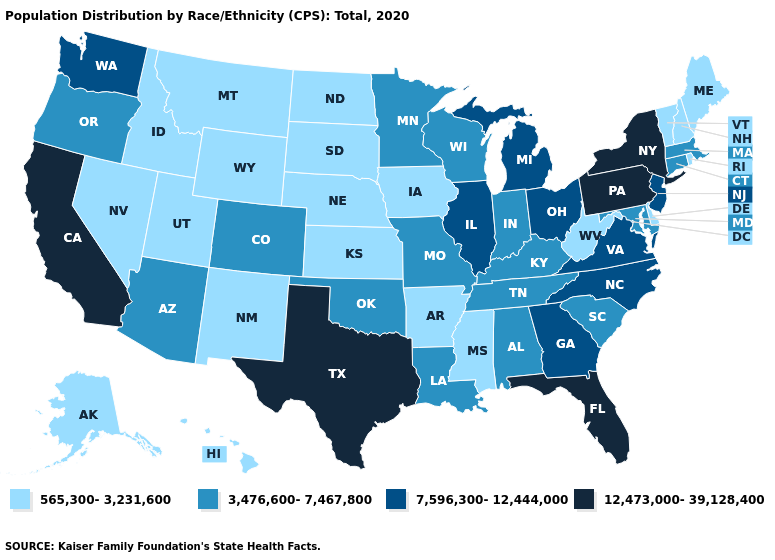What is the value of Kansas?
Answer briefly. 565,300-3,231,600. Name the states that have a value in the range 565,300-3,231,600?
Short answer required. Alaska, Arkansas, Delaware, Hawaii, Idaho, Iowa, Kansas, Maine, Mississippi, Montana, Nebraska, Nevada, New Hampshire, New Mexico, North Dakota, Rhode Island, South Dakota, Utah, Vermont, West Virginia, Wyoming. What is the value of Florida?
Concise answer only. 12,473,000-39,128,400. Which states have the lowest value in the South?
Give a very brief answer. Arkansas, Delaware, Mississippi, West Virginia. Name the states that have a value in the range 12,473,000-39,128,400?
Short answer required. California, Florida, New York, Pennsylvania, Texas. Among the states that border Oregon , which have the highest value?
Write a very short answer. California. Name the states that have a value in the range 7,596,300-12,444,000?
Keep it brief. Georgia, Illinois, Michigan, New Jersey, North Carolina, Ohio, Virginia, Washington. Which states have the lowest value in the Northeast?
Write a very short answer. Maine, New Hampshire, Rhode Island, Vermont. What is the value of Vermont?
Give a very brief answer. 565,300-3,231,600. What is the lowest value in the South?
Keep it brief. 565,300-3,231,600. Among the states that border Vermont , does New York have the highest value?
Be succinct. Yes. What is the lowest value in states that border Idaho?
Short answer required. 565,300-3,231,600. Does New York have the highest value in the USA?
Short answer required. Yes. What is the value of Alaska?
Give a very brief answer. 565,300-3,231,600. Among the states that border New Hampshire , which have the lowest value?
Answer briefly. Maine, Vermont. 